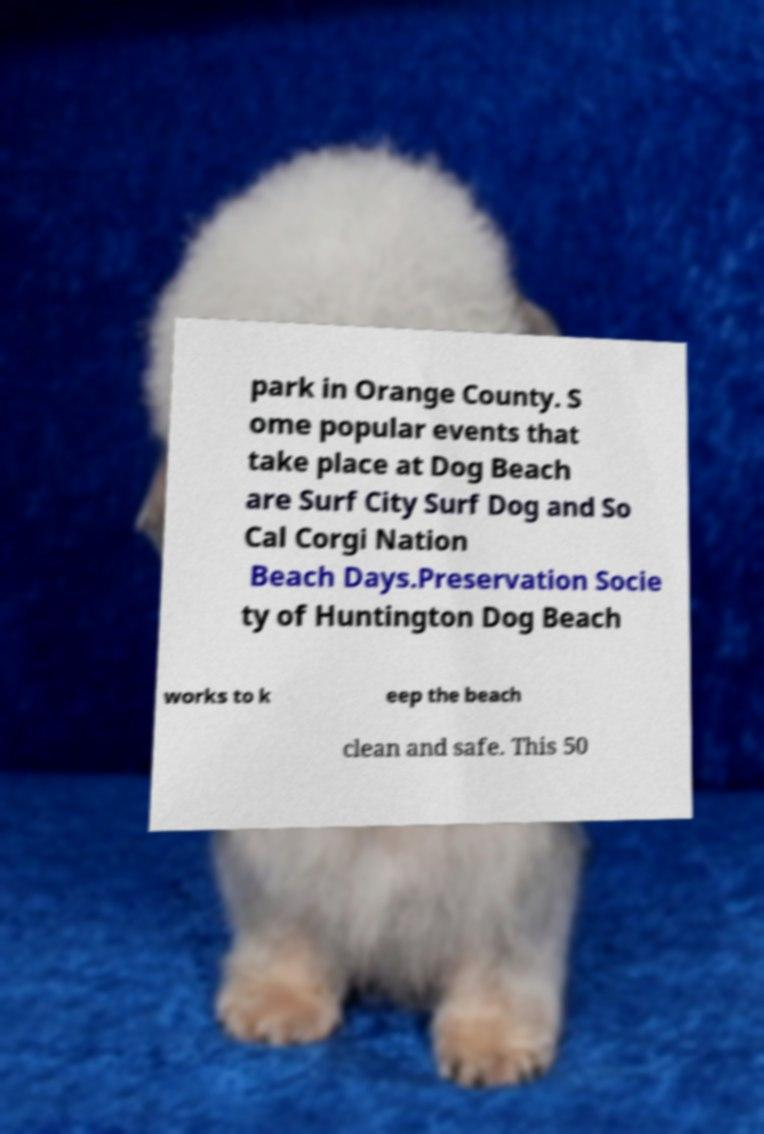Can you read and provide the text displayed in the image?This photo seems to have some interesting text. Can you extract and type it out for me? park in Orange County. S ome popular events that take place at Dog Beach are Surf City Surf Dog and So Cal Corgi Nation Beach Days.Preservation Socie ty of Huntington Dog Beach works to k eep the beach clean and safe. This 50 